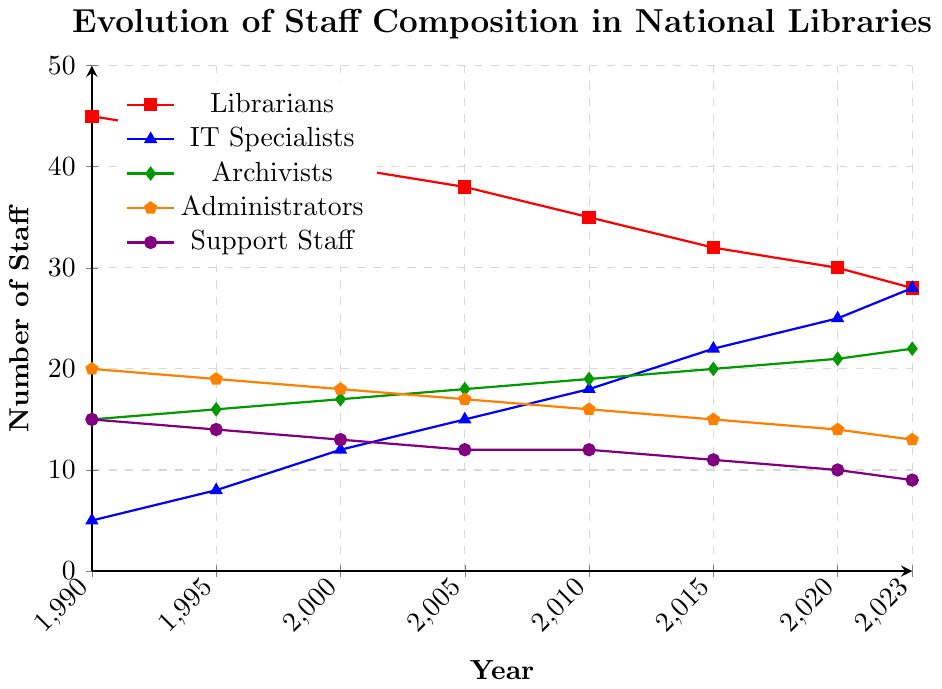Which job role had the highest number of staff in 1990? According to the figure, the red line representing Librarians is the highest at 1990 with a staff count of 45.
Answer: Librarians By how many staff members did the number of IT Specialists increase between 1990 and 2023? In 1990, the number of IT Specialists was 5, and in 2023, it was 28. Thus, the increase is calculated as 28 - 5 = 23.
Answer: 23 Compare the trend of Librarians and IT Specialists over the years. Which role saw a decrease, and which saw an increase? The red line for Librarians shows a consistent decreasing trend, while the blue line for IT Specialists shows a consistent increasing trend.
Answer: Librarians decreased, IT Specialists increased What is the difference in the number of Administrators and Support Staff in 2023? In 2023, the number of Administrators is 13 and the number of Support Staff is 9. The difference is 13 - 9 = 4.
Answer: 4 Which job role has remained the most stable with minimal changes in staff numbers from 1990 to 2023? The green line representing Archivists shows relatively minimal changes, starting at 15 in 1990 and gradually increasing to 22 in 2023.
Answer: Archivists How does the number of Support Staff in 2023 compare to the number in 1990? In 1990, the number of Support Staff was 15 while in 2023, it was 9, indicating a decrease of 6 staff members.
Answer: Decreased by 6 Calculate the total number of staff in 2010 across all job roles. Sum the values of staff members from all roles in 2010: 35 (Librarians) + 18 (IT Specialists) + 19 (Archivists) + 16 (Administrators) + 12 (Support Staff) = 100.
Answer: 100 Which job role had the largest increase in staff between 1990 and 2023? Calculating the increase: IT Specialists from 5 to 28, Archivists from 15 to 22, etc. The largest increase is for IT Specialists (28 - 5) = 23.
Answer: IT Specialists What is the average number of Archivists from 1990 to 2023? The numbers are 15, 16, 17, 18, 19, 20, 21, and 22. The sum is 148. The average is 148 / 8 = 18.5.
Answer: 18.5 